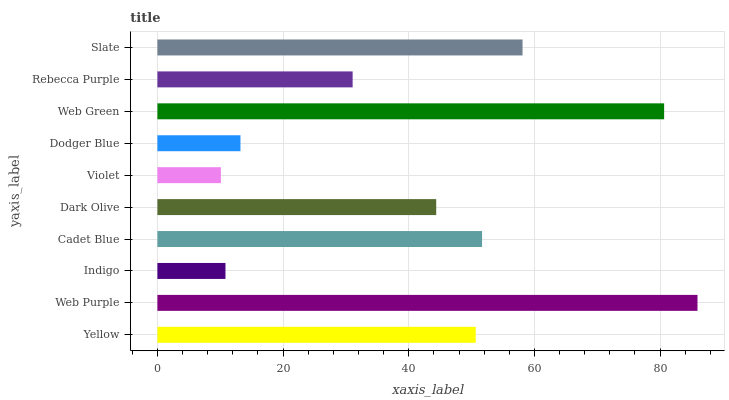Is Violet the minimum?
Answer yes or no. Yes. Is Web Purple the maximum?
Answer yes or no. Yes. Is Indigo the minimum?
Answer yes or no. No. Is Indigo the maximum?
Answer yes or no. No. Is Web Purple greater than Indigo?
Answer yes or no. Yes. Is Indigo less than Web Purple?
Answer yes or no. Yes. Is Indigo greater than Web Purple?
Answer yes or no. No. Is Web Purple less than Indigo?
Answer yes or no. No. Is Yellow the high median?
Answer yes or no. Yes. Is Dark Olive the low median?
Answer yes or no. Yes. Is Cadet Blue the high median?
Answer yes or no. No. Is Slate the low median?
Answer yes or no. No. 